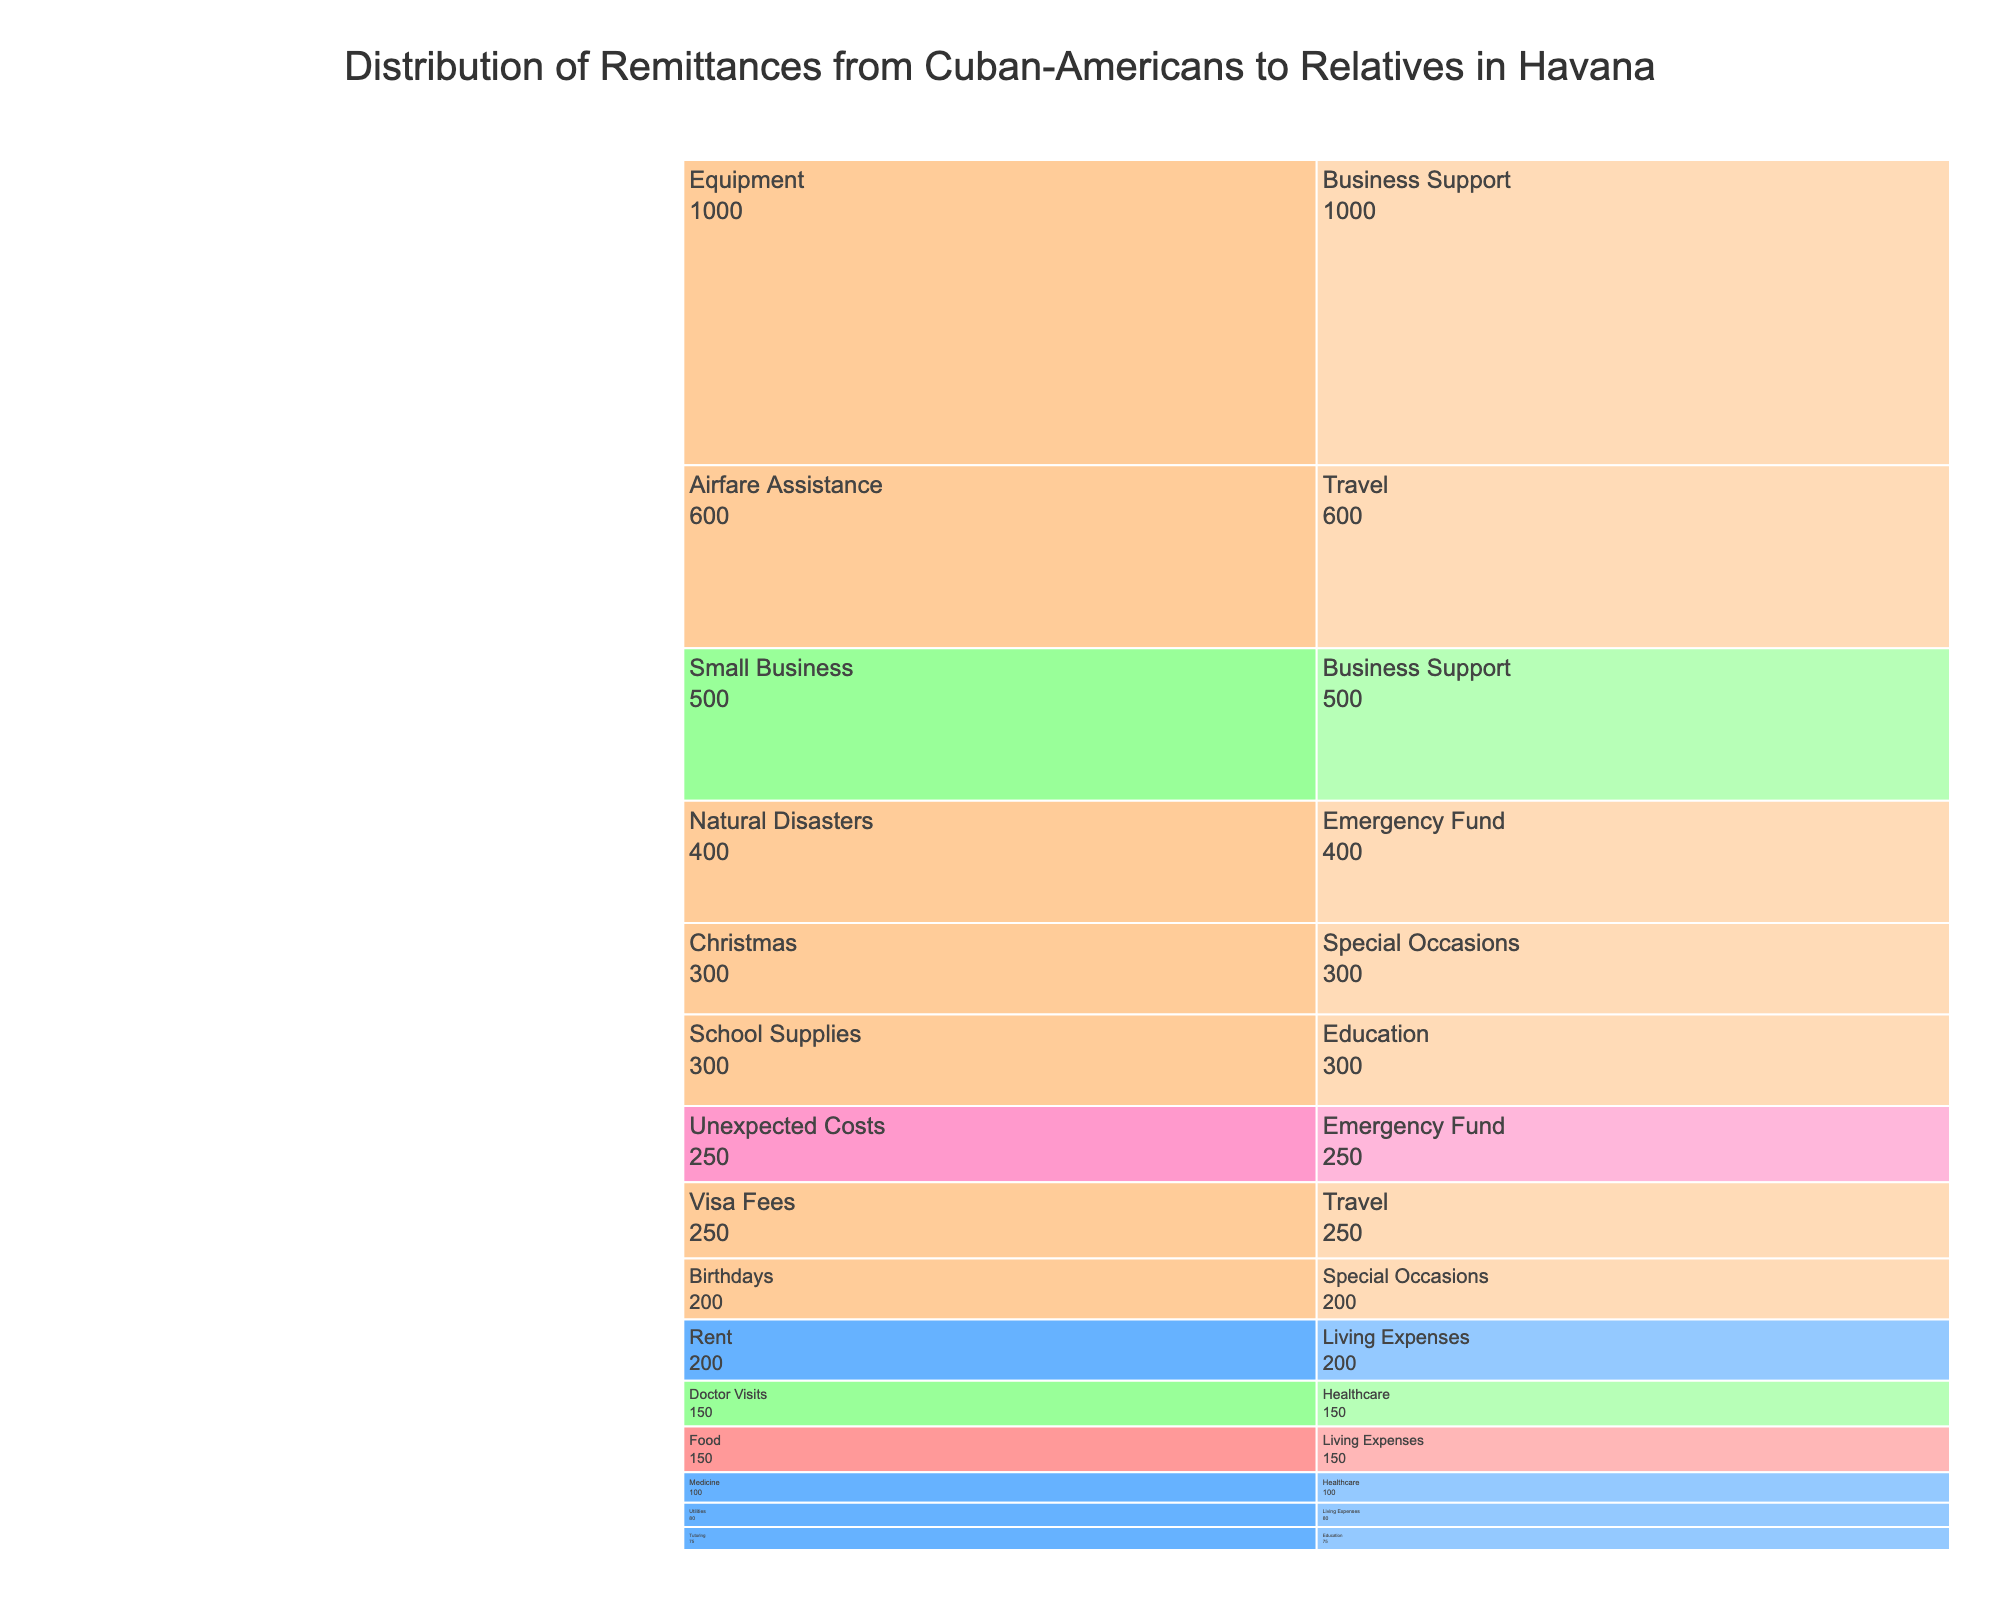What is the title of the chart? The title of the chart is located at the top center and reads "Distribution of Remittances from Cuban-Americans to Relatives in Havana".
Answer: Distribution of Remittances from Cuban-Americans to Relatives in Havana What category receives the most remittance based on the amount? By examining the largest section in the icicle chart, you can see that "Living Expenses" contains the largest amounts combining Food, Utilities, and Rent.
Answer: Living Expenses What is the total remittance amount sent for Healthcare purposes? Summing the values for Medicine ($100) and Doctor Visits ($150) provides the total amount sent for Healthcare. 100 + 150 = 250
Answer: $250 How do the remittances for Education compare in frequency to those for Living Expenses? Education remittances occur annually for School Supplies and monthly for Tutoring, while Living Expenses have weekly, monthly, and annual frequencies for different purposes.
Answer: Living Expenses have more frequent remittances Which category has an annual frequency and the highest amount? From the chart, you can see that Business Support (Equipment) has an annual remittance amount of $1000, which is the highest among annual frequencies.
Answer: Business Support (Equipment) What is the difference in remittance amount between the smallest and largest categories? The smallest remittance amount is for Tutoring ($75), and the largest is for Equipment ($1000). The difference is 1000 - 75 = 925.
Answer: $925 How are the frequencies of Emergency Fund remittances distributed? Emergency Fund remittances are distributed as annually for Natural Disasters ($400) and semi-annually for Unexpected Costs ($250).
Answer: Annually and Semi-annually Which category within Special Occasions has a higher remittance amount? Comparing the values within Special Occasions, Christmas ($300) has a higher amount than Birthdays ($200).
Answer: Christmas What is the combined amount sent yearly (annually) across all categories? Summing all annual remittances: School Supplies ($300), Equipment ($1000), Natural Disasters ($400), Birthdays ($200), Christmas ($300), Visa Fees ($250), Airfare Assistance ($600). The total is 300 + 1000 + 400 + 200 + 300 + 250 + 600 = 3050.
Answer: $3050 What purpose receives funding both quarterly and annually? By noting the consistency in the remittance frequency, Business Support (quarterly for Small Business and annually for Equipment) fits the criteria.
Answer: Business Support 